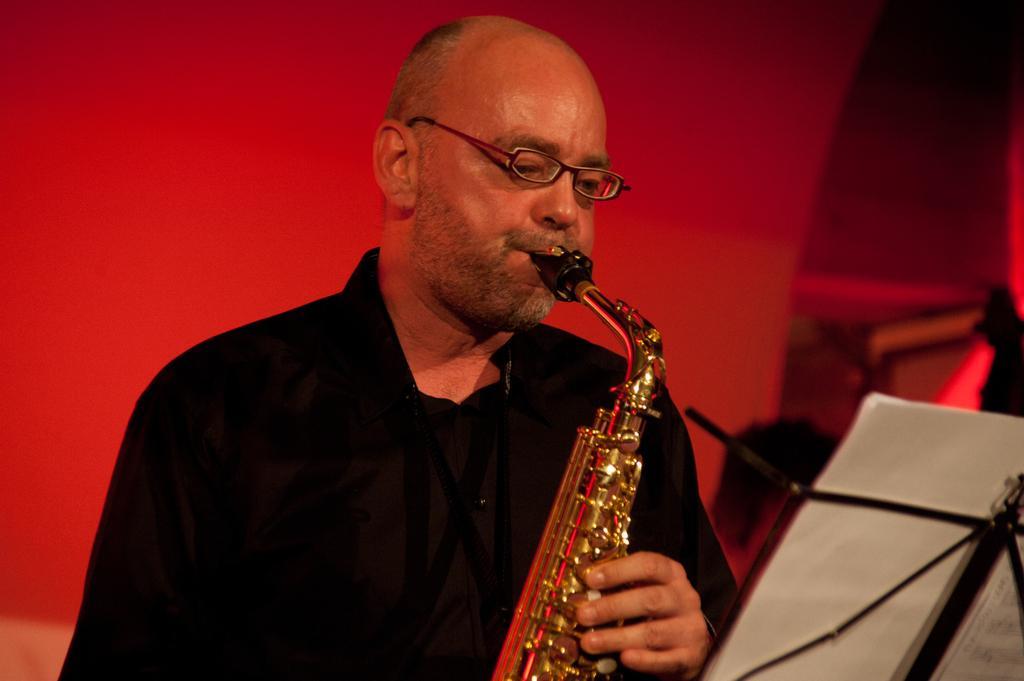Describe this image in one or two sentences. In this image we can see a person playing a musical instrument. In front of the person we can see a book with a stand. The background of the image is red. 